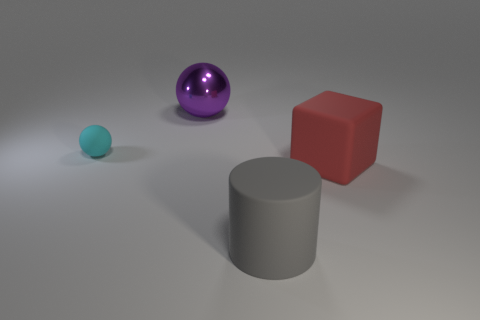Are there any other things that are the same material as the large purple sphere?
Offer a very short reply. No. Is there anything else that has the same size as the rubber ball?
Your answer should be compact. No. The ball that is behind the ball that is on the left side of the purple metallic ball is what color?
Give a very brief answer. Purple. Is there a gray cylinder of the same size as the red rubber thing?
Provide a succinct answer. Yes. What material is the small cyan sphere that is left of the matte object that is to the right of the big rubber thing that is on the left side of the rubber block?
Ensure brevity in your answer.  Rubber. There is a large thing right of the gray matte cylinder; how many rubber things are right of it?
Provide a succinct answer. 0. Does the thing that is on the right side of the gray thing have the same size as the rubber ball?
Give a very brief answer. No. How many red things are the same shape as the cyan matte thing?
Offer a terse response. 0. The big gray object is what shape?
Your answer should be compact. Cylinder. Are there the same number of tiny rubber spheres to the right of the small cyan matte object and small gray matte blocks?
Keep it short and to the point. Yes. 